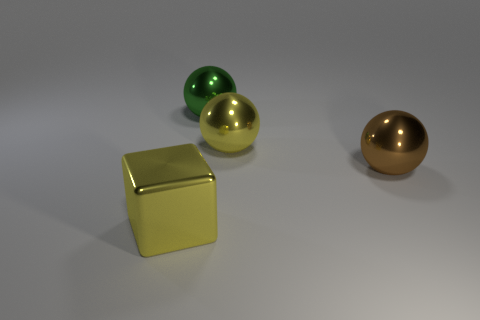Subtract all blocks. How many objects are left? 3 Subtract 1 balls. How many balls are left? 2 Subtract all blue cubes. Subtract all cyan cylinders. How many cubes are left? 1 Subtract all red spheres. How many red blocks are left? 0 Subtract all tiny rubber cylinders. Subtract all big brown shiny spheres. How many objects are left? 3 Add 2 large cubes. How many large cubes are left? 3 Add 3 green spheres. How many green spheres exist? 4 Add 2 green rubber objects. How many objects exist? 6 Subtract all yellow balls. How many balls are left? 2 Subtract 0 green cylinders. How many objects are left? 4 